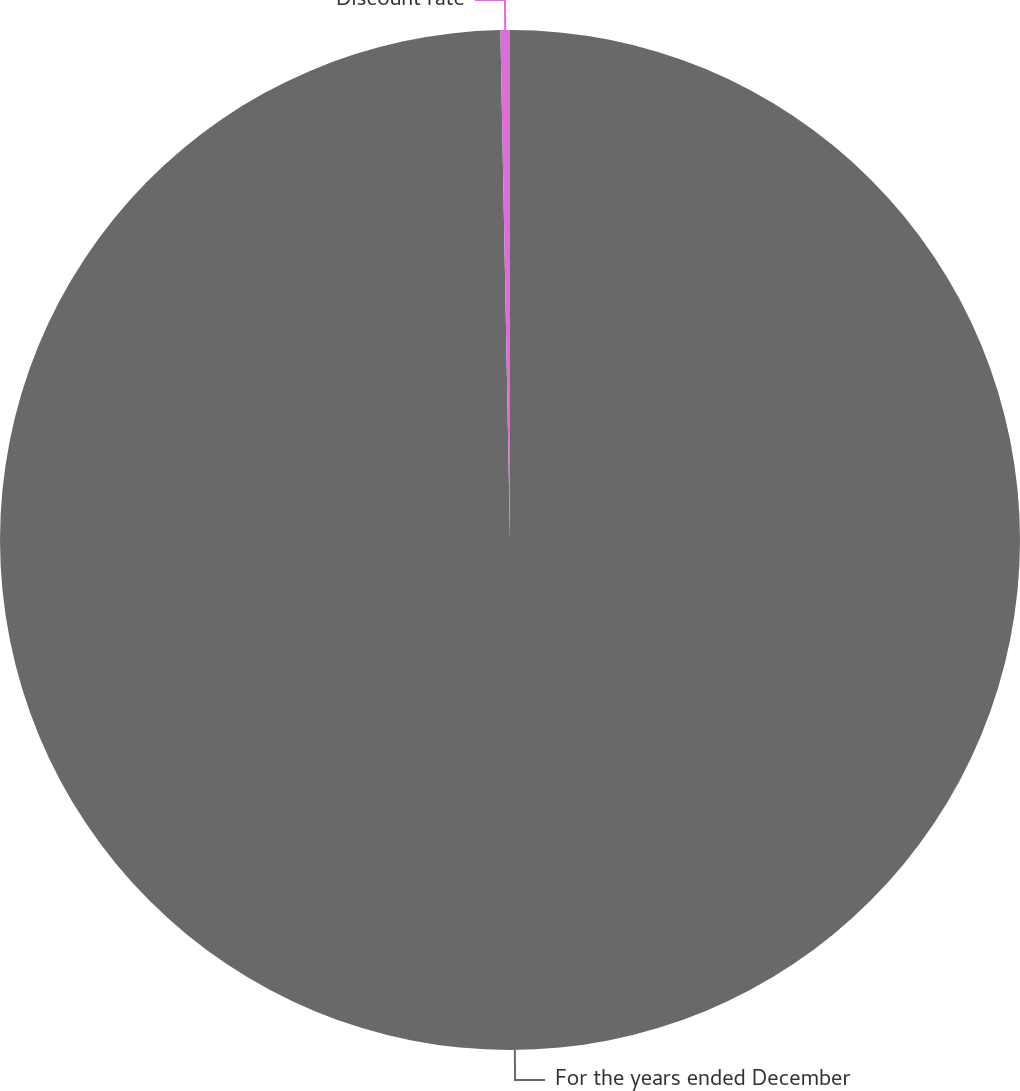<chart> <loc_0><loc_0><loc_500><loc_500><pie_chart><fcel>For the years ended December<fcel>Discount rate<nl><fcel>99.7%<fcel>0.3%<nl></chart> 